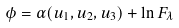<formula> <loc_0><loc_0><loc_500><loc_500>\phi = \alpha ( u _ { 1 } , u _ { 2 } , u _ { 3 } ) + \ln F _ { \lambda }</formula> 